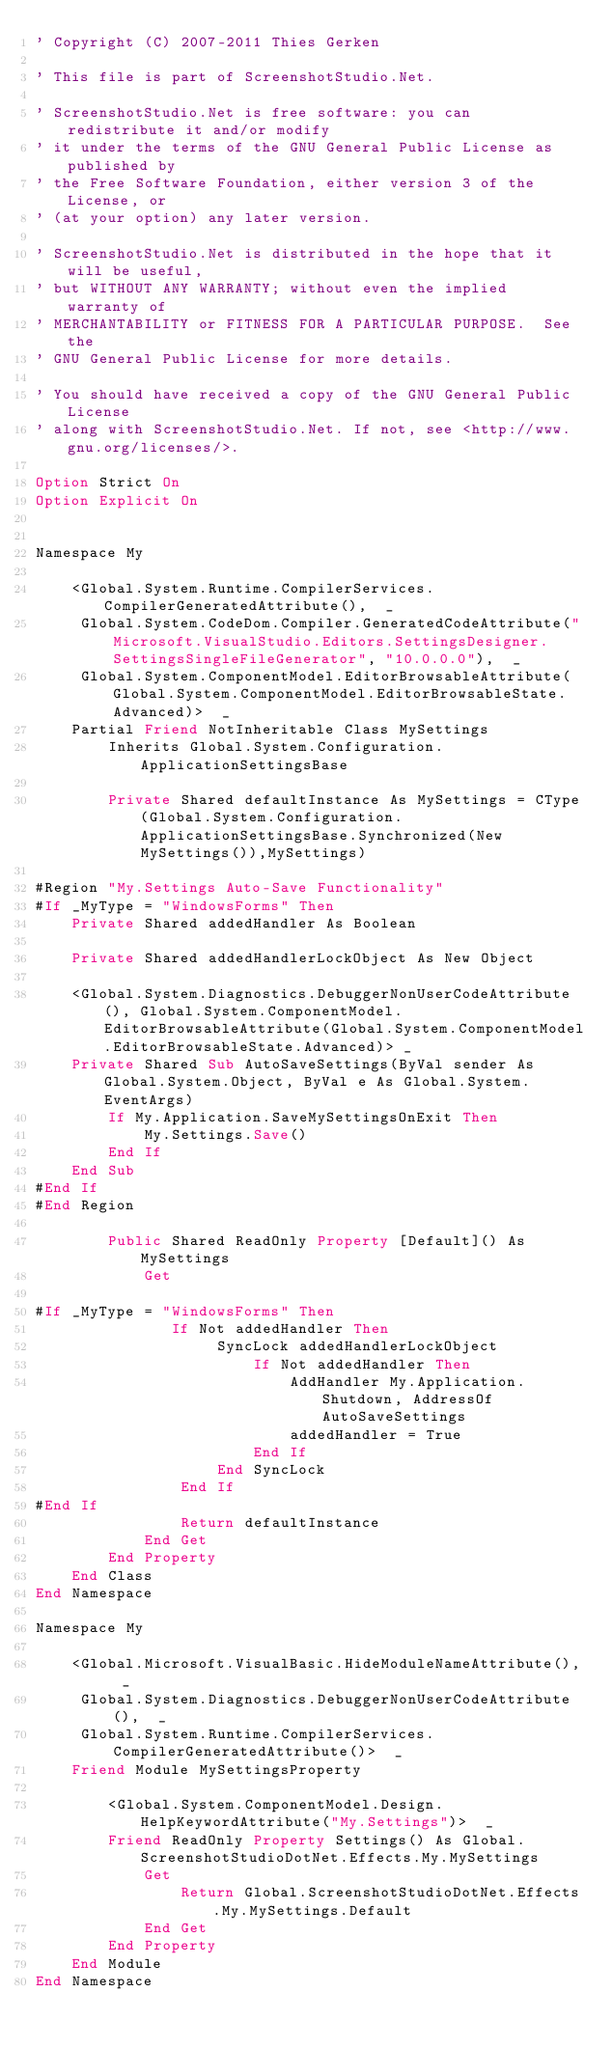<code> <loc_0><loc_0><loc_500><loc_500><_VisualBasic_>' Copyright (C) 2007-2011 Thies Gerken

' This file is part of ScreenshotStudio.Net.

' ScreenshotStudio.Net is free software: you can redistribute it and/or modify
' it under the terms of the GNU General Public License as published by
' the Free Software Foundation, either version 3 of the License, or
' (at your option) any later version.

' ScreenshotStudio.Net is distributed in the hope that it will be useful,
' but WITHOUT ANY WARRANTY; without even the implied warranty of
' MERCHANTABILITY or FITNESS FOR A PARTICULAR PURPOSE.  See the
' GNU General Public License for more details.

' You should have received a copy of the GNU General Public License
' along with ScreenshotStudio.Net. If not, see <http://www.gnu.org/licenses/>.

Option Strict On
Option Explicit On


Namespace My
    
    <Global.System.Runtime.CompilerServices.CompilerGeneratedAttribute(),  _
     Global.System.CodeDom.Compiler.GeneratedCodeAttribute("Microsoft.VisualStudio.Editors.SettingsDesigner.SettingsSingleFileGenerator", "10.0.0.0"),  _
     Global.System.ComponentModel.EditorBrowsableAttribute(Global.System.ComponentModel.EditorBrowsableState.Advanced)>  _
    Partial Friend NotInheritable Class MySettings
        Inherits Global.System.Configuration.ApplicationSettingsBase
        
        Private Shared defaultInstance As MySettings = CType(Global.System.Configuration.ApplicationSettingsBase.Synchronized(New MySettings()),MySettings)
        
#Region "My.Settings Auto-Save Functionality"
#If _MyType = "WindowsForms" Then
    Private Shared addedHandler As Boolean

    Private Shared addedHandlerLockObject As New Object

    <Global.System.Diagnostics.DebuggerNonUserCodeAttribute(), Global.System.ComponentModel.EditorBrowsableAttribute(Global.System.ComponentModel.EditorBrowsableState.Advanced)> _
    Private Shared Sub AutoSaveSettings(ByVal sender As Global.System.Object, ByVal e As Global.System.EventArgs)
        If My.Application.SaveMySettingsOnExit Then
            My.Settings.Save()
        End If
    End Sub
#End If
#End Region
        
        Public Shared ReadOnly Property [Default]() As MySettings
            Get
                
#If _MyType = "WindowsForms" Then
               If Not addedHandler Then
                    SyncLock addedHandlerLockObject
                        If Not addedHandler Then
                            AddHandler My.Application.Shutdown, AddressOf AutoSaveSettings
                            addedHandler = True
                        End If
                    End SyncLock
                End If
#End If
                Return defaultInstance
            End Get
        End Property
    End Class
End Namespace

Namespace My
    
    <Global.Microsoft.VisualBasic.HideModuleNameAttribute(),  _
     Global.System.Diagnostics.DebuggerNonUserCodeAttribute(),  _
     Global.System.Runtime.CompilerServices.CompilerGeneratedAttribute()>  _
    Friend Module MySettingsProperty
        
        <Global.System.ComponentModel.Design.HelpKeywordAttribute("My.Settings")>  _
        Friend ReadOnly Property Settings() As Global.ScreenshotStudioDotNet.Effects.My.MySettings
            Get
                Return Global.ScreenshotStudioDotNet.Effects.My.MySettings.Default
            End Get
        End Property
    End Module
End Namespace
</code> 